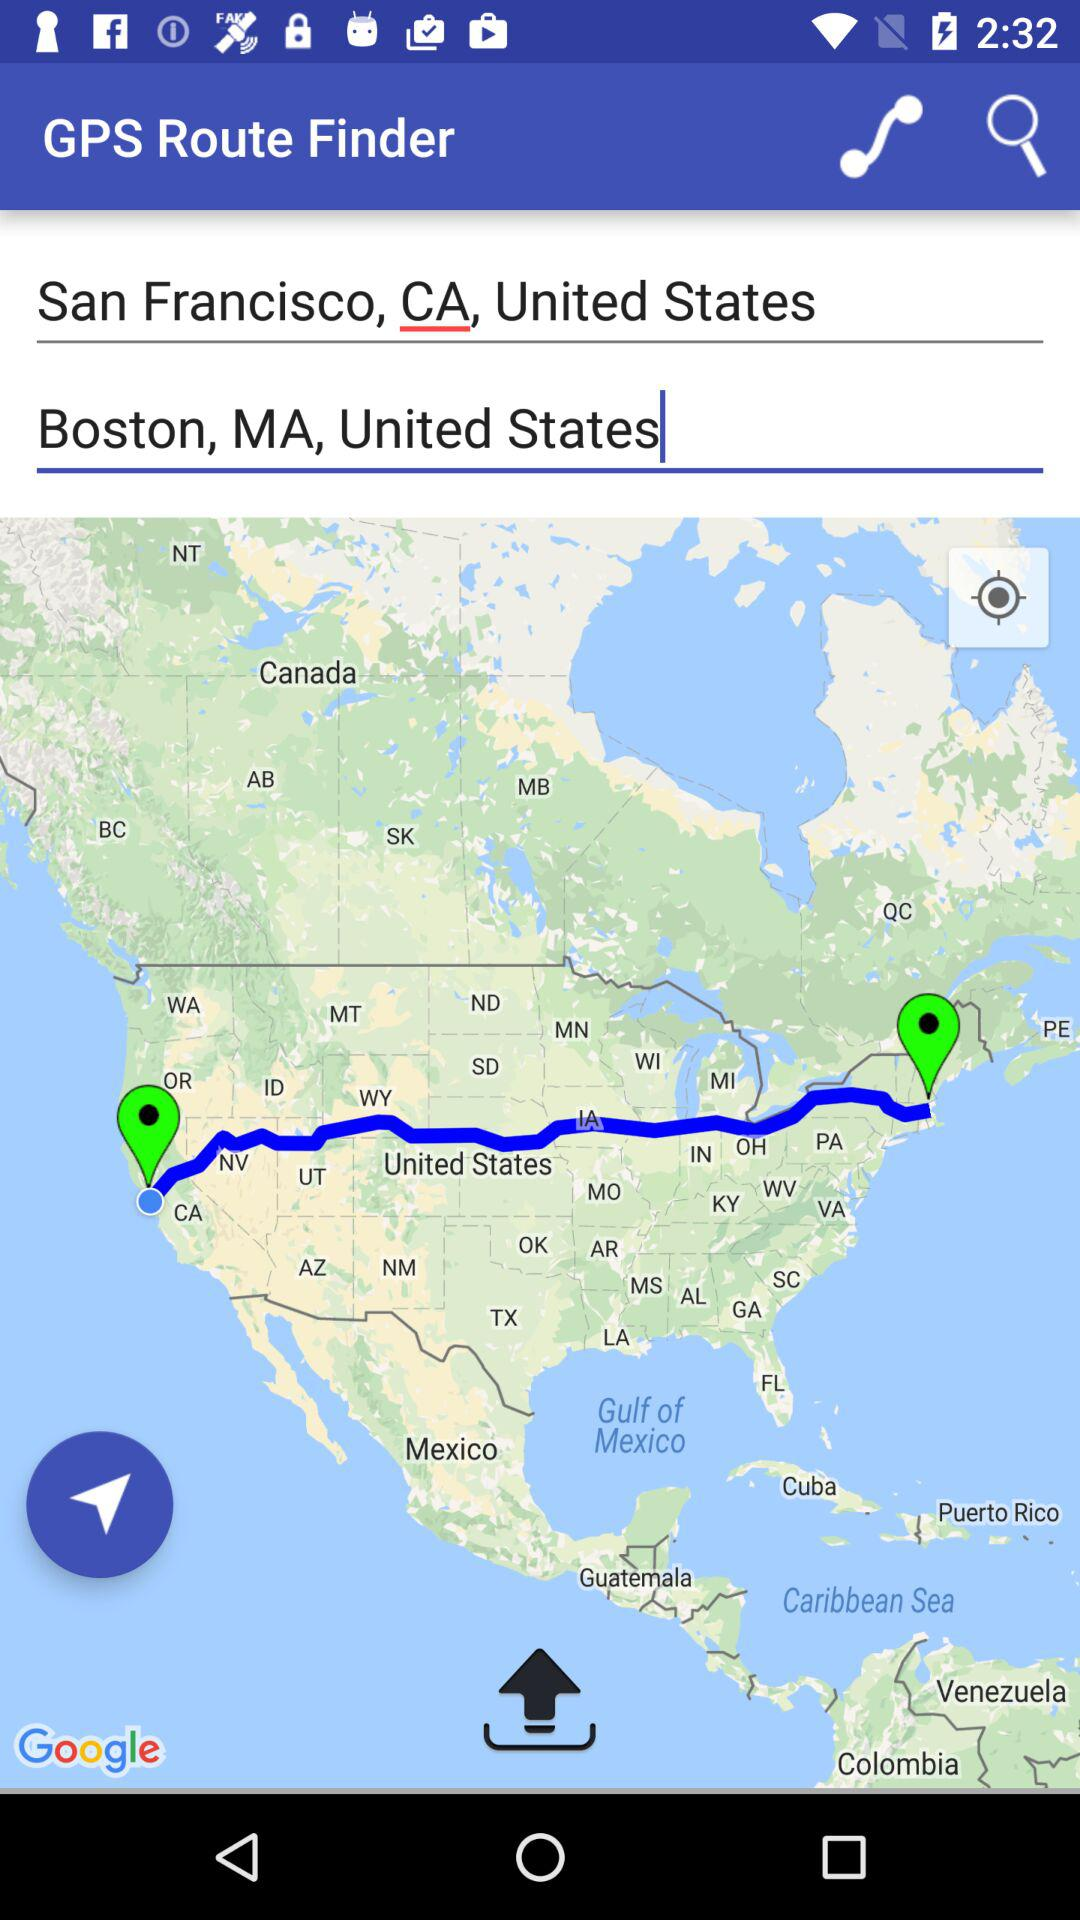What is the given destination location? The given destination location is Boston, MA, United States. 